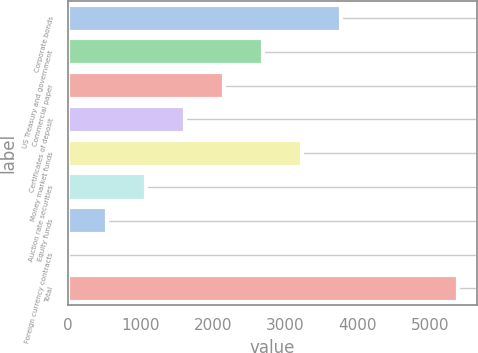Convert chart to OTSL. <chart><loc_0><loc_0><loc_500><loc_500><bar_chart><fcel>Corporate bonds<fcel>US Treasury and government<fcel>Commercial paper<fcel>Certificates of deposit<fcel>Money market funds<fcel>Auction rate securities<fcel>Equity funds<fcel>Foreign currency contracts<fcel>Total<nl><fcel>3772.94<fcel>2695.3<fcel>2156.48<fcel>1617.66<fcel>3234.12<fcel>1078.84<fcel>540.02<fcel>1.2<fcel>5389.4<nl></chart> 